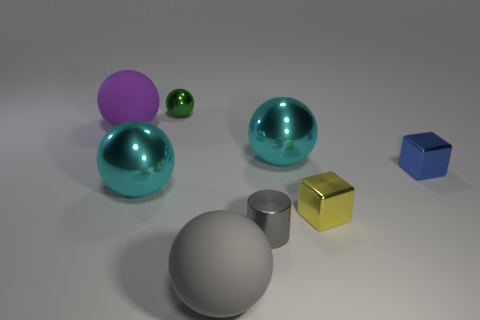There is a cyan shiny ball on the left side of the green ball; is it the same size as the tiny gray object?
Offer a very short reply. No. There is a big cyan object behind the tiny blue thing; what is it made of?
Your response must be concise. Metal. Is the number of objects on the left side of the big gray sphere the same as the number of big matte objects that are on the right side of the gray cylinder?
Ensure brevity in your answer.  No. What color is the other large rubber object that is the same shape as the purple thing?
Provide a short and direct response. Gray. Is there anything else of the same color as the metal cylinder?
Your response must be concise. Yes. How many shiny things are tiny yellow things or blue cubes?
Provide a short and direct response. 2. Does the small sphere have the same color as the tiny cylinder?
Offer a very short reply. No. Are there more cubes that are in front of the yellow metal thing than small blue metallic blocks?
Your response must be concise. No. What number of other objects are there of the same material as the tiny cylinder?
Provide a short and direct response. 5. What number of small things are either blue shiny blocks or yellow blocks?
Provide a short and direct response. 2. 